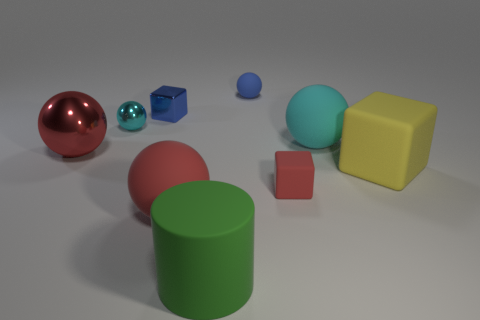Subtract all purple spheres. Subtract all yellow blocks. How many spheres are left? 5 Add 1 tiny gray rubber blocks. How many objects exist? 10 Subtract all balls. How many objects are left? 4 Subtract all green rubber blocks. Subtract all big matte cubes. How many objects are left? 8 Add 3 cyan matte balls. How many cyan matte balls are left? 4 Add 8 big cyan metallic things. How many big cyan metallic things exist? 8 Subtract 0 green cubes. How many objects are left? 9 